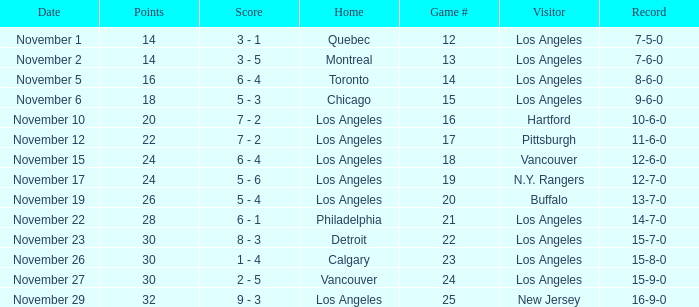What is the number of points of the game less than number 17 with an 11-6-0 record? None. 